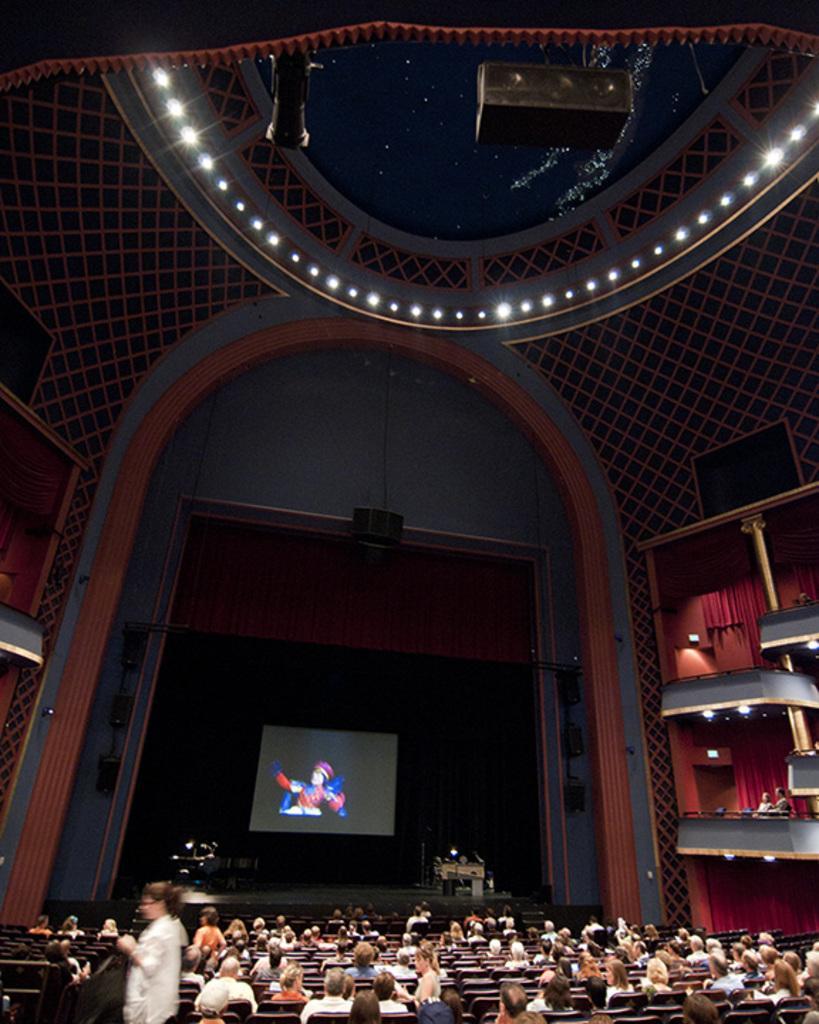How would you summarize this image in a sentence or two? In this image we can see sky, electric lights, projector, display screen, musical instruments, dais, persons sitting on the benches, walls and curtains. 